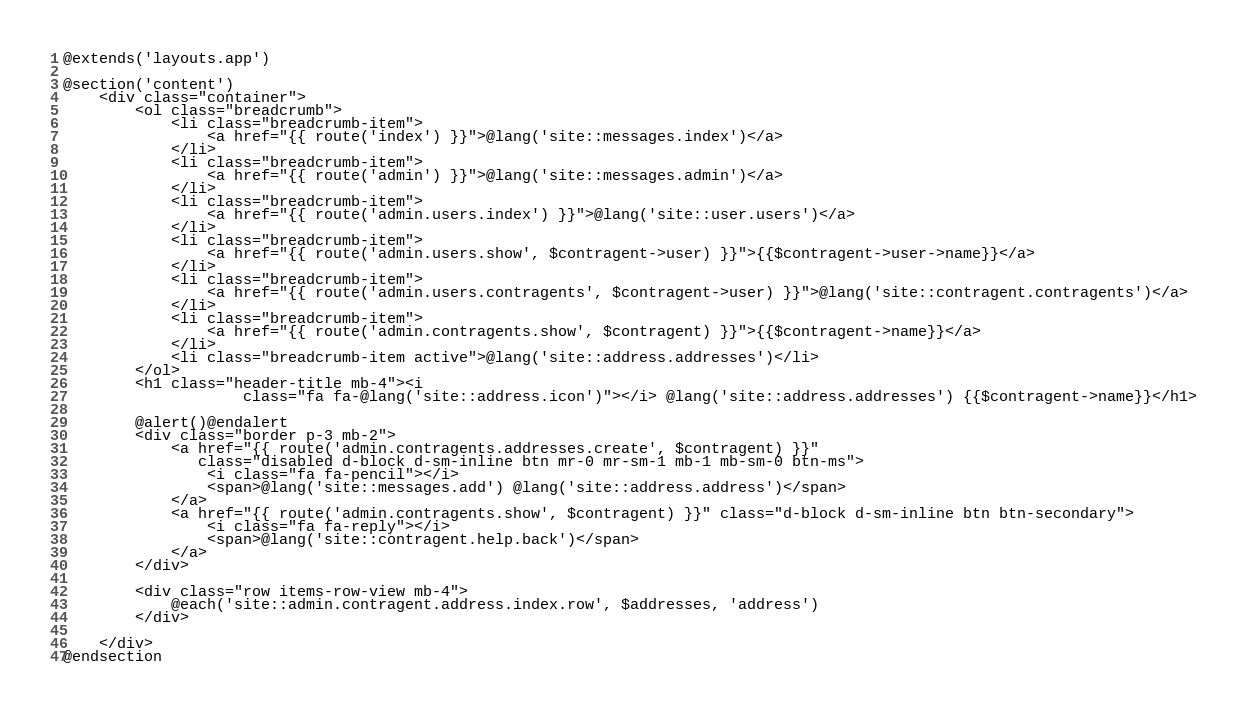<code> <loc_0><loc_0><loc_500><loc_500><_PHP_>@extends('layouts.app')

@section('content')
    <div class="container">
        <ol class="breadcrumb">
            <li class="breadcrumb-item">
                <a href="{{ route('index') }}">@lang('site::messages.index')</a>
            </li>
            <li class="breadcrumb-item">
                <a href="{{ route('admin') }}">@lang('site::messages.admin')</a>
            </li>
            <li class="breadcrumb-item">
                <a href="{{ route('admin.users.index') }}">@lang('site::user.users')</a>
            </li>
            <li class="breadcrumb-item">
                <a href="{{ route('admin.users.show', $contragent->user) }}">{{$contragent->user->name}}</a>
            </li>
            <li class="breadcrumb-item">
                <a href="{{ route('admin.users.contragents', $contragent->user) }}">@lang('site::contragent.contragents')</a>
            </li>
            <li class="breadcrumb-item">
                <a href="{{ route('admin.contragents.show', $contragent) }}">{{$contragent->name}}</a>
            </li>
            <li class="breadcrumb-item active">@lang('site::address.addresses')</li>
        </ol>
        <h1 class="header-title mb-4"><i
                    class="fa fa-@lang('site::address.icon')"></i> @lang('site::address.addresses') {{$contragent->name}}</h1>

        @alert()@endalert
        <div class="border p-3 mb-2">
            <a href="{{ route('admin.contragents.addresses.create', $contragent) }}"
               class="disabled d-block d-sm-inline btn mr-0 mr-sm-1 mb-1 mb-sm-0 btn-ms">
                <i class="fa fa-pencil"></i>
                <span>@lang('site::messages.add') @lang('site::address.address')</span>
            </a>
            <a href="{{ route('admin.contragents.show', $contragent) }}" class="d-block d-sm-inline btn btn-secondary">
                <i class="fa fa-reply"></i>
                <span>@lang('site::contragent.help.back')</span>
            </a>
        </div>

        <div class="row items-row-view mb-4">
            @each('site::admin.contragent.address.index.row', $addresses, 'address')
        </div>

    </div>
@endsection
</code> 